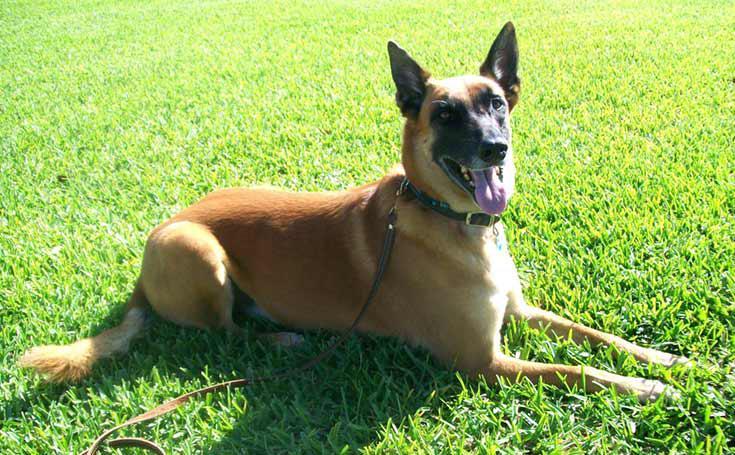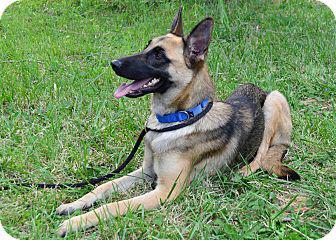The first image is the image on the left, the second image is the image on the right. Examine the images to the left and right. Is the description "Each image contains a single german shepherd, and each dog wears a leash." accurate? Answer yes or no. Yes. The first image is the image on the left, the second image is the image on the right. Analyze the images presented: Is the assertion "There are two dogs with pointed ears and tongues sticking out." valid? Answer yes or no. Yes. 